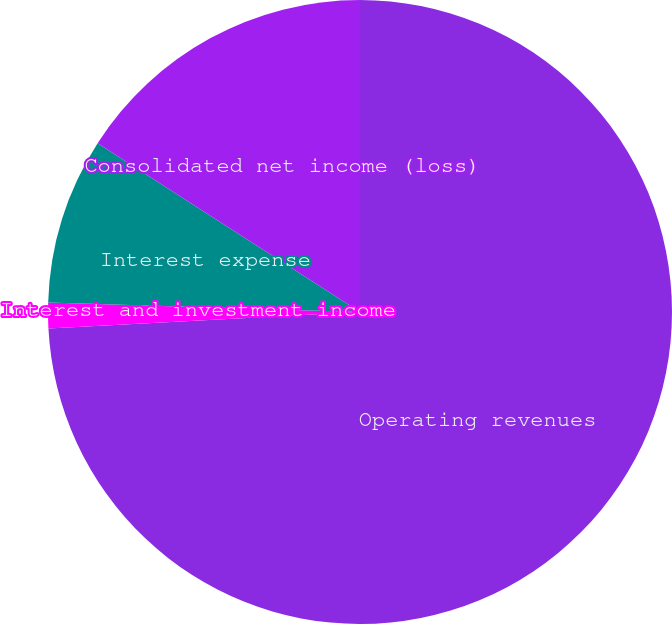Convert chart to OTSL. <chart><loc_0><loc_0><loc_500><loc_500><pie_chart><fcel>Operating revenues<fcel>Interest and investment income<fcel>Interest expense<fcel>Consolidated net income (loss)<nl><fcel>74.16%<fcel>1.33%<fcel>8.61%<fcel>15.9%<nl></chart> 